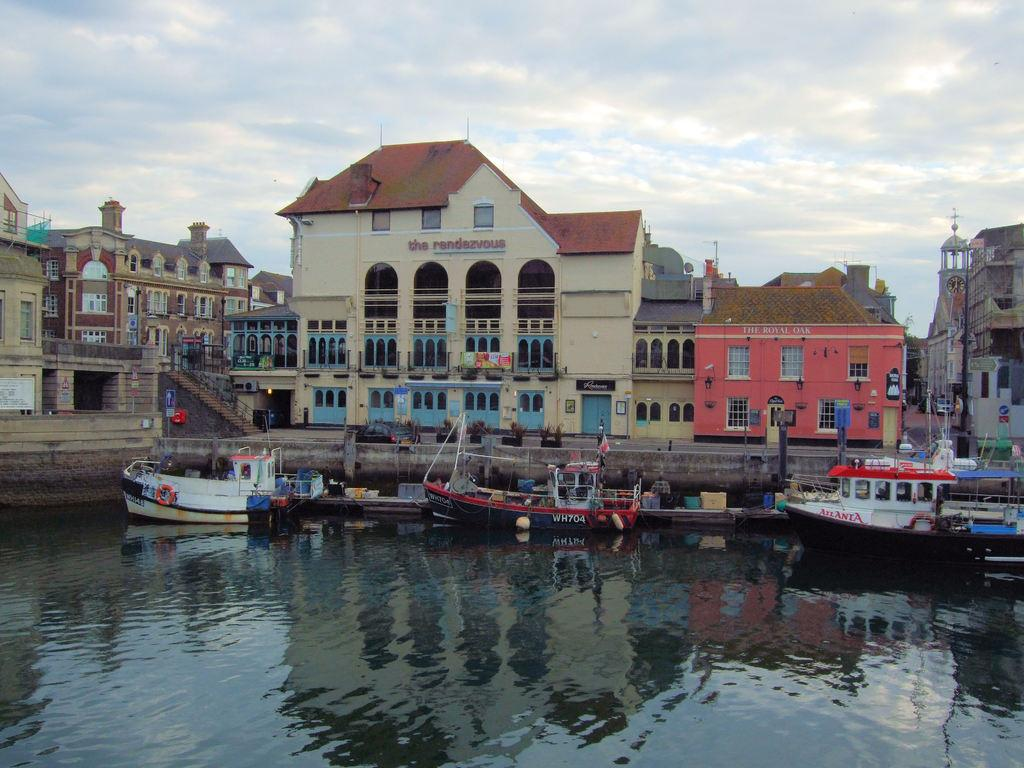<image>
Give a short and clear explanation of the subsequent image. Boats docked by a building that is named "The Rendezvous". 